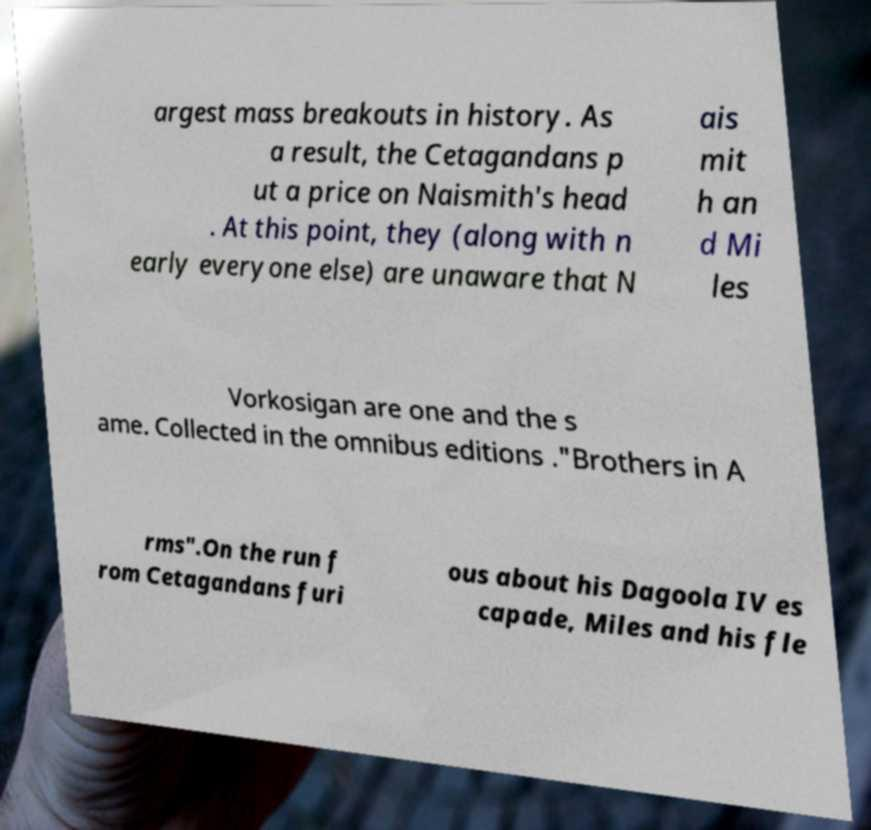Please read and relay the text visible in this image. What does it say? argest mass breakouts in history. As a result, the Cetagandans p ut a price on Naismith's head . At this point, they (along with n early everyone else) are unaware that N ais mit h an d Mi les Vorkosigan are one and the s ame. Collected in the omnibus editions ."Brothers in A rms".On the run f rom Cetagandans furi ous about his Dagoola IV es capade, Miles and his fle 